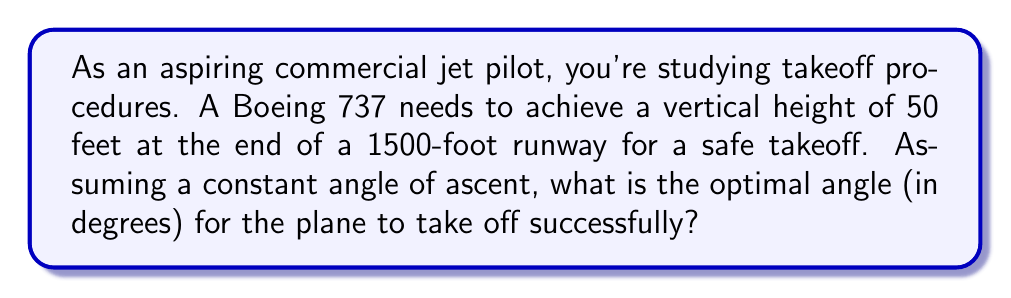Help me with this question. Let's approach this step-by-step:

1) We can visualize this scenario as a right triangle, where:
   - The runway length is the base of the triangle
   - The required height is the opposite side
   - The plane's path is the hypotenuse

2) We need to find the angle between the base (runway) and the hypotenuse (plane's path). This is the angle of ascent.

3) We can use the tangent function to find this angle. Recall that:

   $$ \tan(\theta) = \frac{\text{opposite}}{\text{adjacent}} $$

4) In our case:
   - opposite = 50 feet (required height)
   - adjacent = 1500 feet (runway length)

5) Let's plug these values into the tangent function:

   $$ \tan(\theta) = \frac{50}{1500} = \frac{1}{30} $$

6) To find the angle, we need to use the inverse tangent (arctan) function:

   $$ \theta = \arctan(\frac{1}{30}) $$

7) Using a calculator or computer, we can evaluate this:

   $$ \theta \approx 1.91 \text{ degrees} $$

8) Rounding to two decimal places gives us the final answer.
Answer: $1.91°$ 